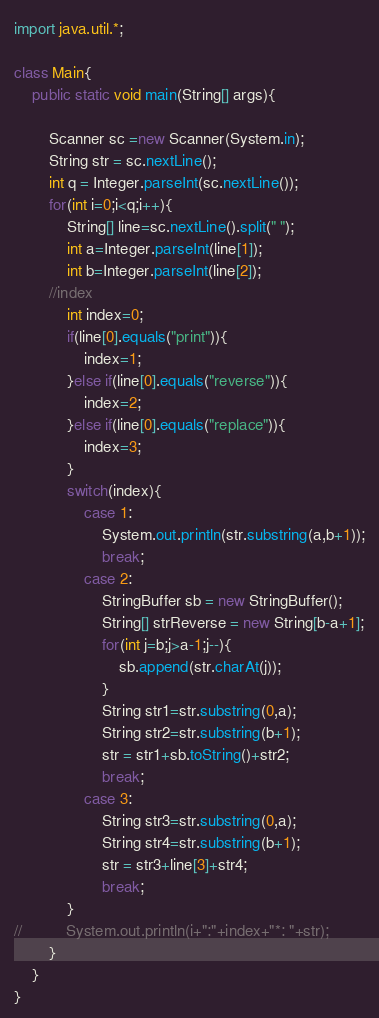<code> <loc_0><loc_0><loc_500><loc_500><_Java_>import java.util.*;

class Main{
	public static void main(String[] args){
		
		Scanner sc =new Scanner(System.in);
		String str = sc.nextLine();
		int q = Integer.parseInt(sc.nextLine());
		for(int i=0;i<q;i++){
			String[] line=sc.nextLine().split(" ");
			int a=Integer.parseInt(line[1]);
			int b=Integer.parseInt(line[2]);
		//index	
			int index=0;
			if(line[0].equals("print")){
				index=1;
			}else if(line[0].equals("reverse")){
				index=2;
			}else if(line[0].equals("replace")){
				index=3;
			}
			switch(index){
				case 1:
					System.out.println(str.substring(a,b+1));
					break;
				case 2:
					StringBuffer sb = new StringBuffer();
					String[] strReverse = new String[b-a+1];
					for(int j=b;j>a-1;j--){
						sb.append(str.charAt(j));
					}
					String str1=str.substring(0,a);
					String str2=str.substring(b+1);
					str = str1+sb.toString()+str2;
					break;	
				case 3:
					String str3=str.substring(0,a);
					String str4=str.substring(b+1);
					str = str3+line[3]+str4;
					break;
			}
//			System.out.println(i+":"+index+"*: "+str);
		}
	}
}</code> 